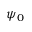<formula> <loc_0><loc_0><loc_500><loc_500>\psi _ { 0 }</formula> 